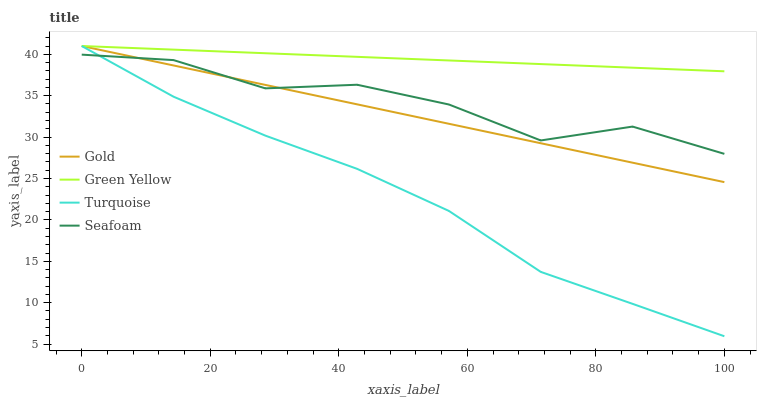Does Turquoise have the minimum area under the curve?
Answer yes or no. Yes. Does Green Yellow have the maximum area under the curve?
Answer yes or no. Yes. Does Seafoam have the minimum area under the curve?
Answer yes or no. No. Does Seafoam have the maximum area under the curve?
Answer yes or no. No. Is Gold the smoothest?
Answer yes or no. Yes. Is Seafoam the roughest?
Answer yes or no. Yes. Is Green Yellow the smoothest?
Answer yes or no. No. Is Green Yellow the roughest?
Answer yes or no. No. Does Turquoise have the lowest value?
Answer yes or no. Yes. Does Seafoam have the lowest value?
Answer yes or no. No. Does Gold have the highest value?
Answer yes or no. Yes. Does Seafoam have the highest value?
Answer yes or no. No. Is Seafoam less than Green Yellow?
Answer yes or no. Yes. Is Green Yellow greater than Seafoam?
Answer yes or no. Yes. Does Green Yellow intersect Gold?
Answer yes or no. Yes. Is Green Yellow less than Gold?
Answer yes or no. No. Is Green Yellow greater than Gold?
Answer yes or no. No. Does Seafoam intersect Green Yellow?
Answer yes or no. No. 